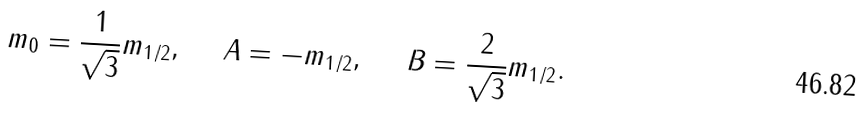Convert formula to latex. <formula><loc_0><loc_0><loc_500><loc_500>m _ { 0 } = \frac { 1 } { \sqrt { 3 } } m _ { 1 / 2 } , \quad \ A = - m _ { 1 / 2 } , \quad \ B = \frac { 2 } { \sqrt { 3 } } m _ { 1 / 2 } .</formula> 